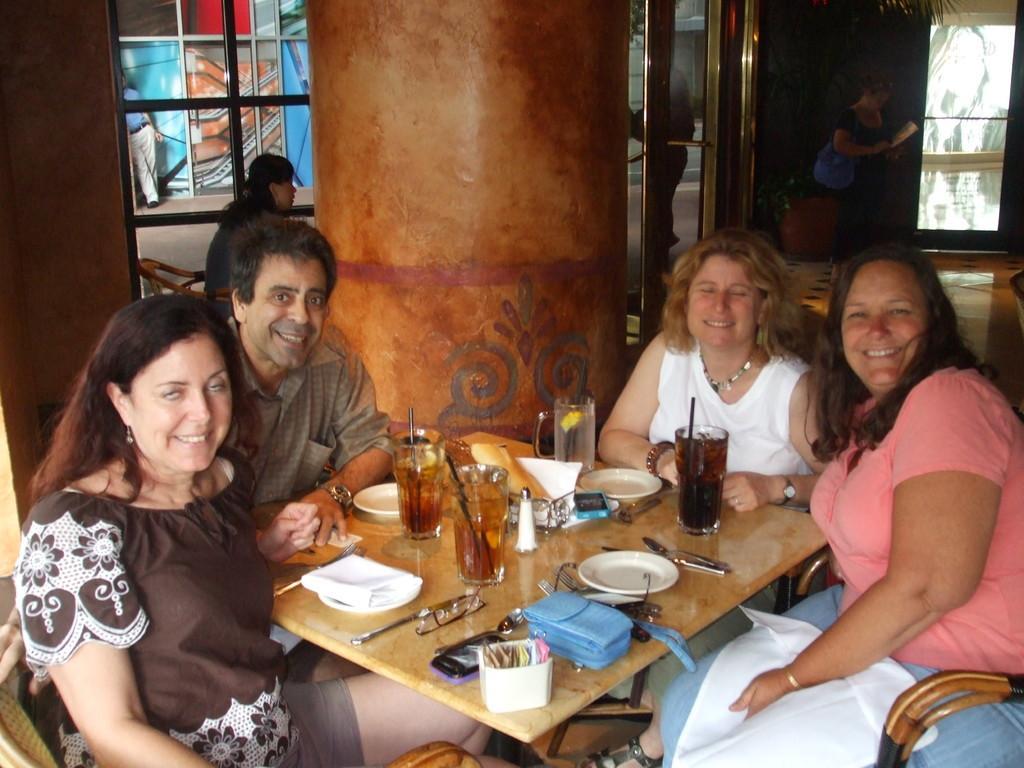Can you describe this image briefly? It seems to be the image is inside the restaurant. In the image there are group of people sitting on chair in front of a table, on table we can see glass with some drink,straw,spoon,knife,plate,tissues. In background there is a pillow and few people are standing and a door which is closed. 